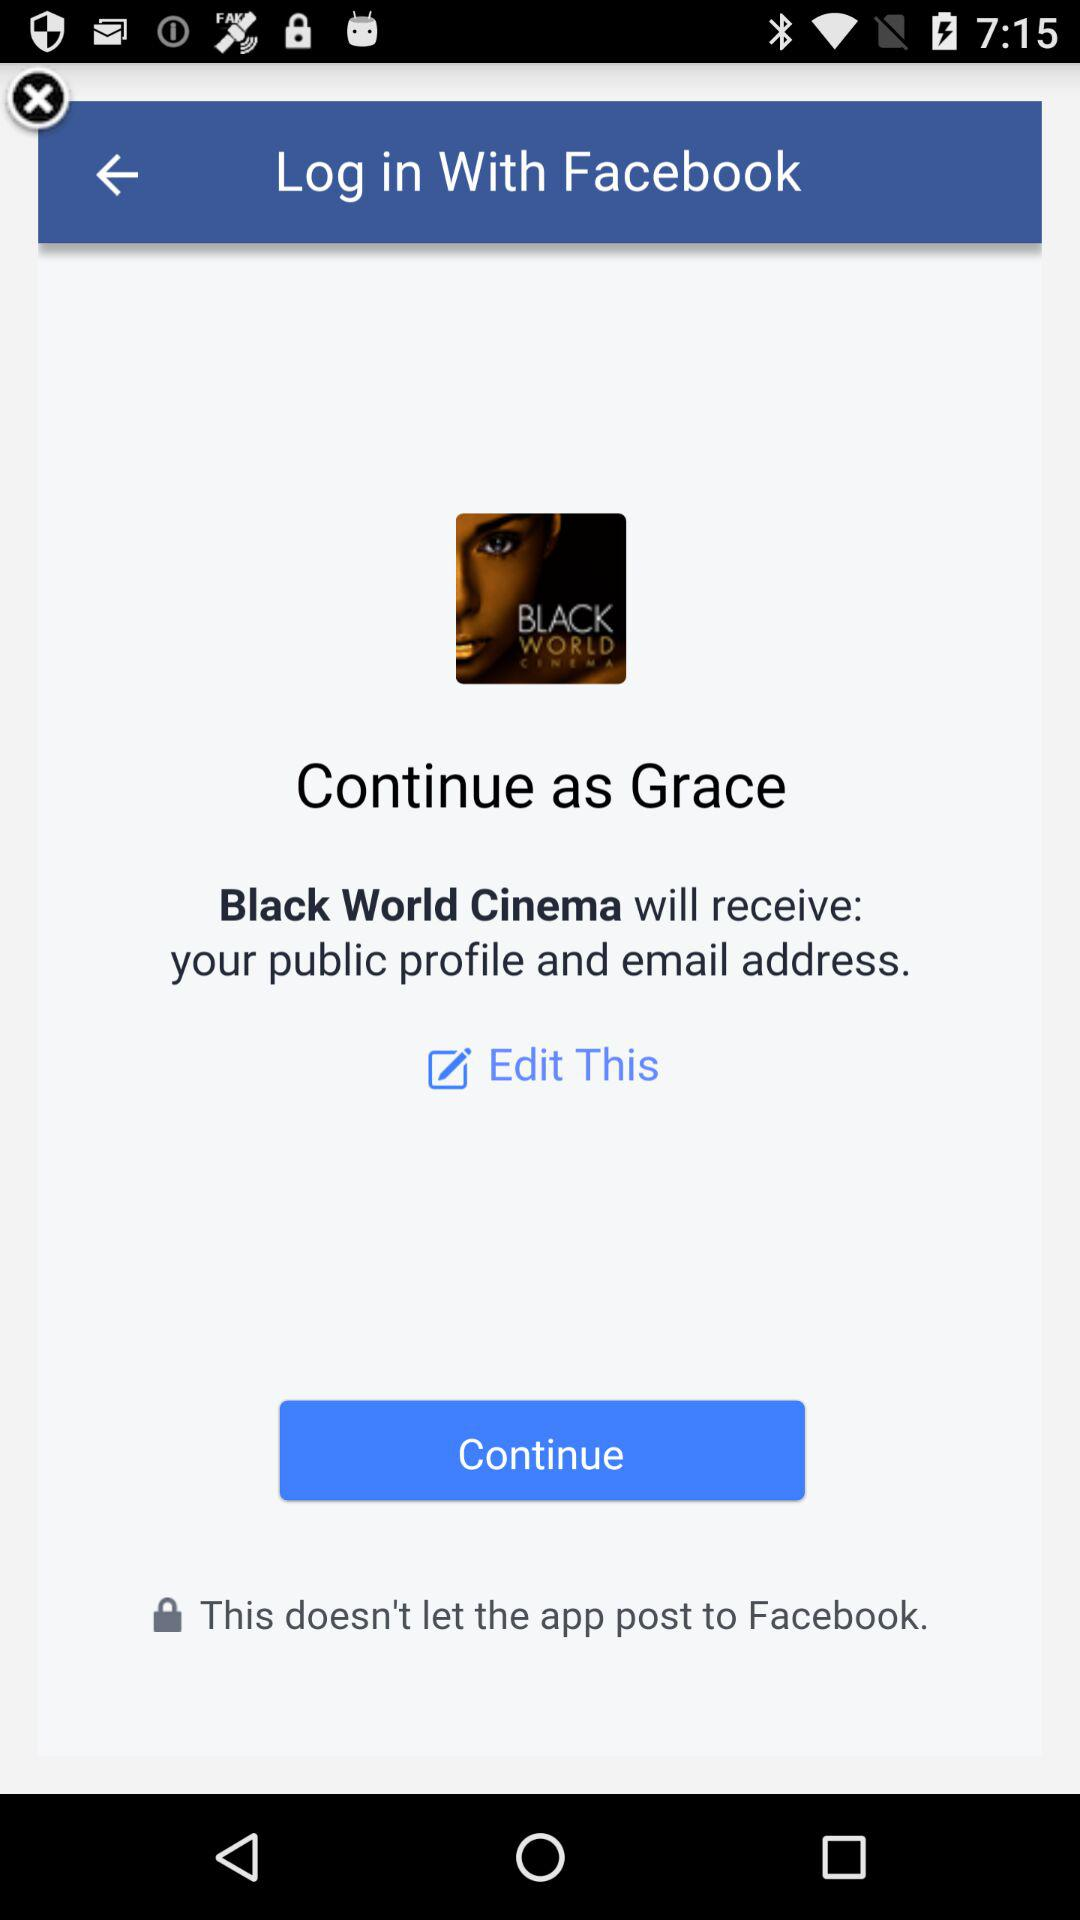Who will receive the public profile and email address? The public profile and email address will be received by "Black World Cinema". 